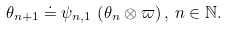Convert formula to latex. <formula><loc_0><loc_0><loc_500><loc_500>\theta _ { n + 1 } \doteq \psi _ { n , 1 } \, \left ( \theta _ { n } \otimes \varpi \right ) , \, n \in \mathbb { N } .</formula> 